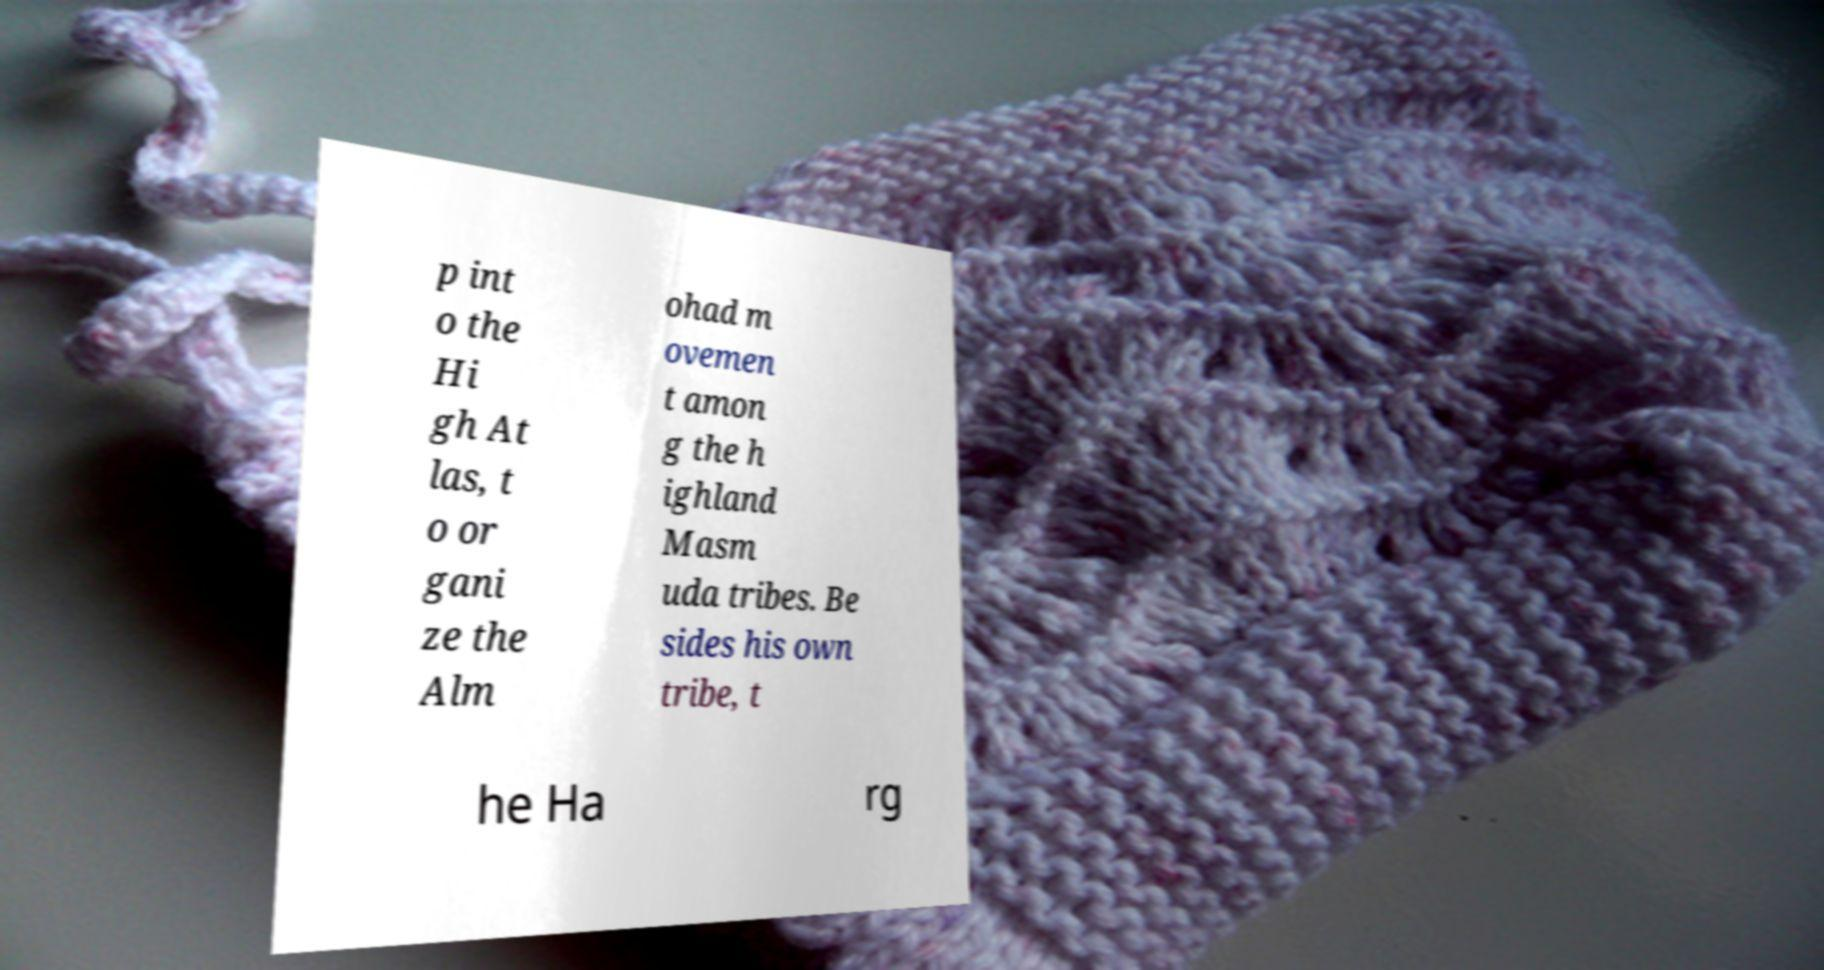There's text embedded in this image that I need extracted. Can you transcribe it verbatim? p int o the Hi gh At las, t o or gani ze the Alm ohad m ovemen t amon g the h ighland Masm uda tribes. Be sides his own tribe, t he Ha rg 